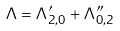<formula> <loc_0><loc_0><loc_500><loc_500>\Lambda = \Lambda ^ { \prime } _ { 2 , 0 } + \Lambda ^ { \prime \prime } _ { 0 , 2 }</formula> 